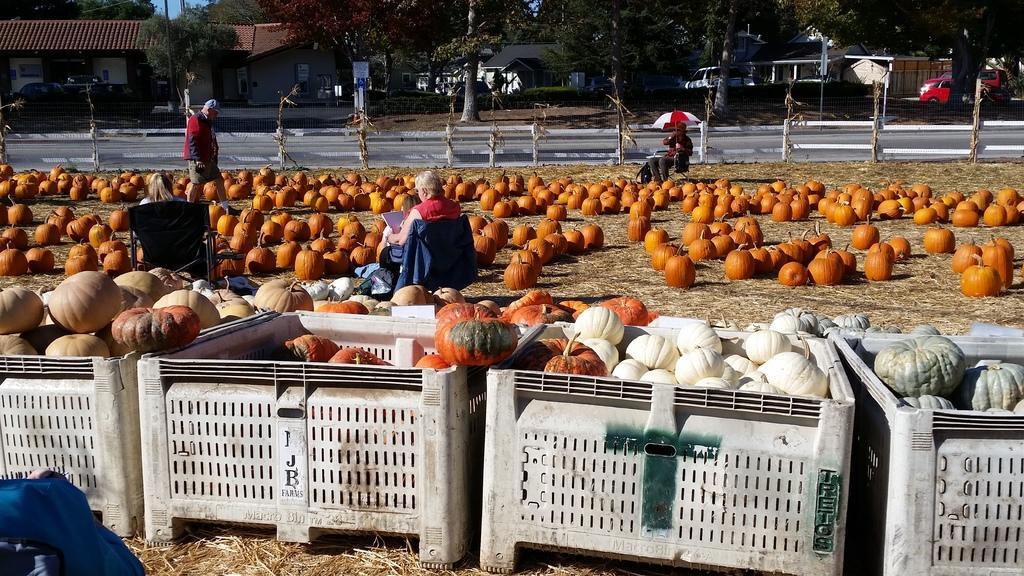How would you summarize this image in a sentence or two? This image consists of many pumpkins. On the right, the pumpkins are in white and gray color. At the bottom, there is dry grass on the ground. In the background, there are houses and many trees along with the cars. In the front, we can see three persons in this image. 